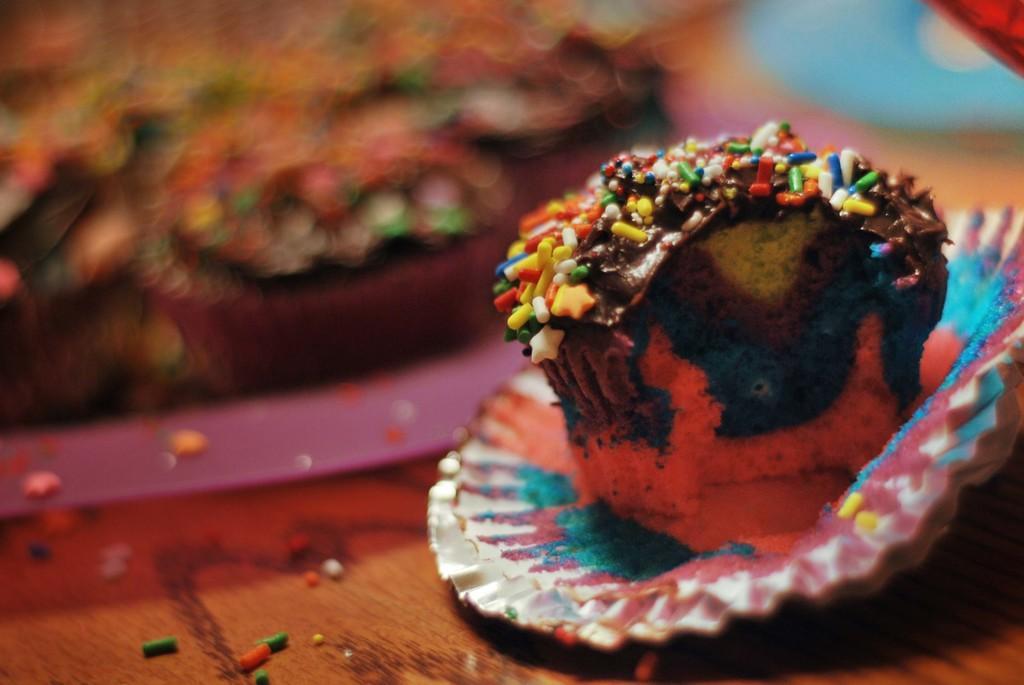In one or two sentences, can you explain what this image depicts? This image consists of a cupcake kept on a table along with a wrapper. And there are stuffing on the cake. The background is blurred. 